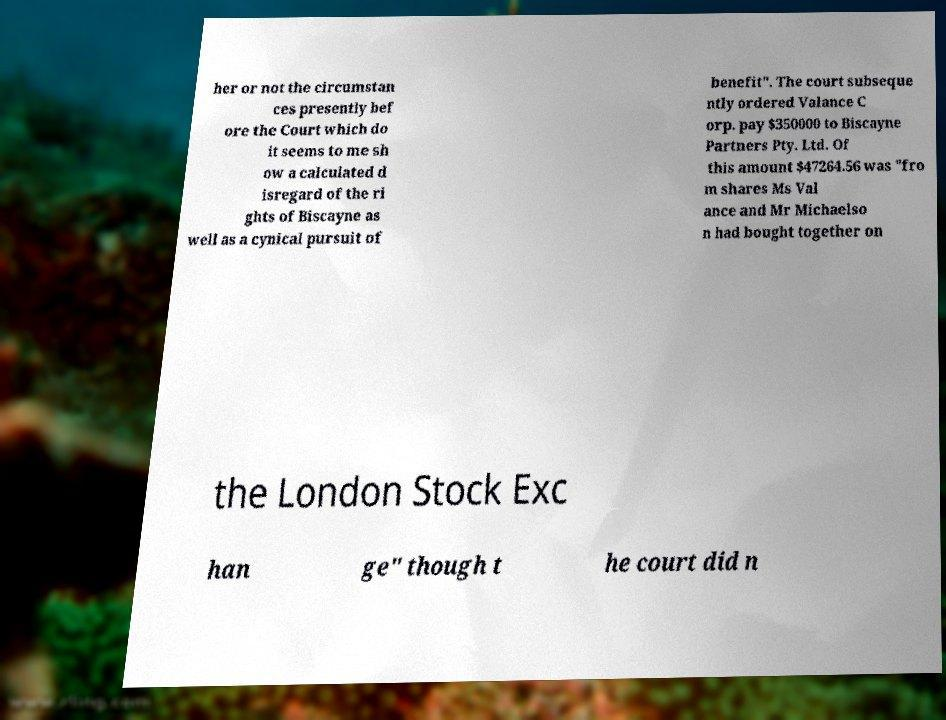Could you extract and type out the text from this image? her or not the circumstan ces presently bef ore the Court which do it seems to me sh ow a calculated d isregard of the ri ghts of Biscayne as well as a cynical pursuit of benefit". The court subseque ntly ordered Valance C orp. pay $350000 to Biscayne Partners Pty. Ltd. Of this amount $47264.56 was "fro m shares Ms Val ance and Mr Michaelso n had bought together on the London Stock Exc han ge" though t he court did n 